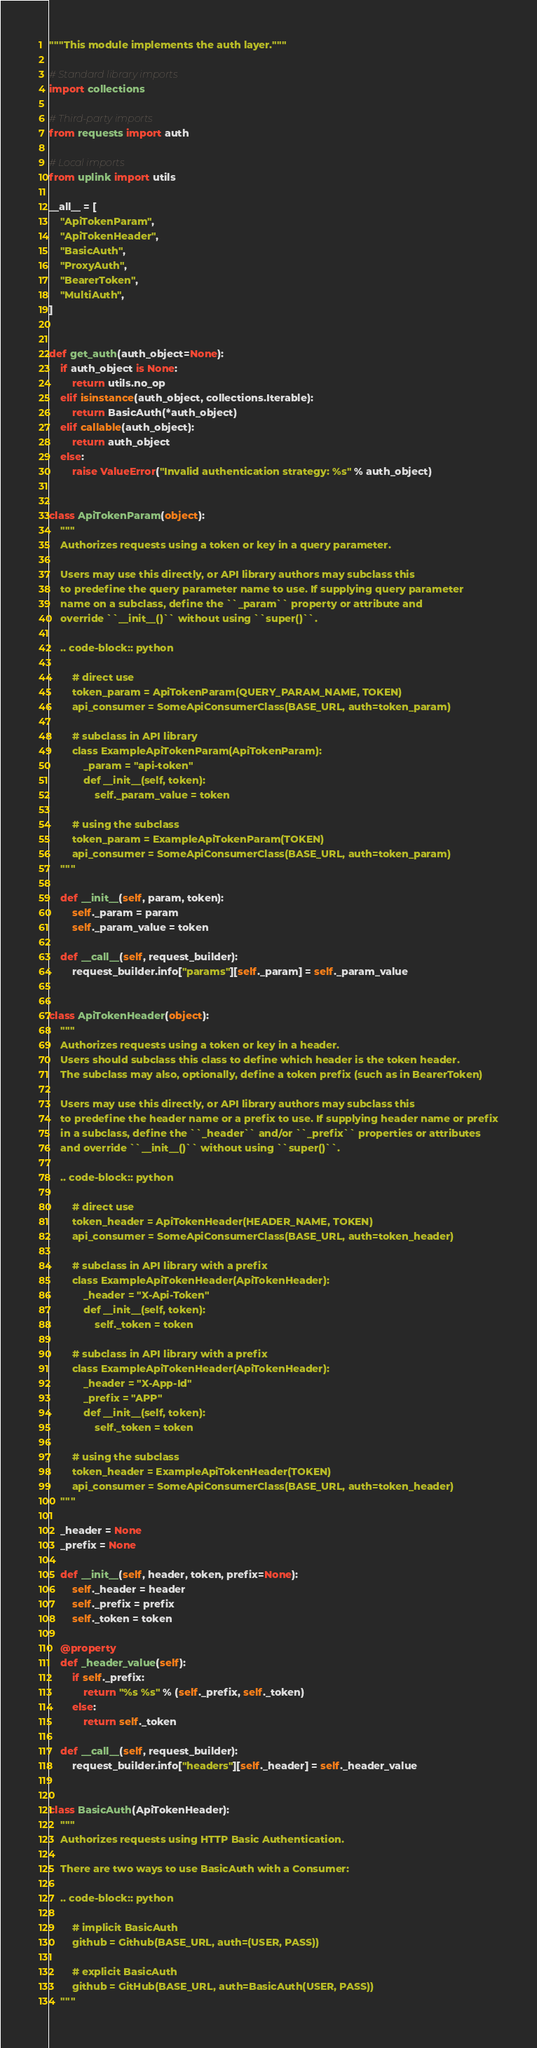<code> <loc_0><loc_0><loc_500><loc_500><_Python_>"""This module implements the auth layer."""

# Standard library imports
import collections

# Third-party imports
from requests import auth

# Local imports
from uplink import utils

__all__ = [
    "ApiTokenParam",
    "ApiTokenHeader",
    "BasicAuth",
    "ProxyAuth",
    "BearerToken",
    "MultiAuth",
]


def get_auth(auth_object=None):
    if auth_object is None:
        return utils.no_op
    elif isinstance(auth_object, collections.Iterable):
        return BasicAuth(*auth_object)
    elif callable(auth_object):
        return auth_object
    else:
        raise ValueError("Invalid authentication strategy: %s" % auth_object)


class ApiTokenParam(object):
    """
    Authorizes requests using a token or key in a query parameter.

    Users may use this directly, or API library authors may subclass this
    to predefine the query parameter name to use. If supplying query parameter
    name on a subclass, define the ``_param`` property or attribute and
    override ``__init__()`` without using ``super()``.

    .. code-block:: python

        # direct use
        token_param = ApiTokenParam(QUERY_PARAM_NAME, TOKEN)
        api_consumer = SomeApiConsumerClass(BASE_URL, auth=token_param)

        # subclass in API library
        class ExampleApiTokenParam(ApiTokenParam):
            _param = "api-token"
            def __init__(self, token):
                self._param_value = token

        # using the subclass
        token_param = ExampleApiTokenParam(TOKEN)
        api_consumer = SomeApiConsumerClass(BASE_URL, auth=token_param)
    """

    def __init__(self, param, token):
        self._param = param
        self._param_value = token

    def __call__(self, request_builder):
        request_builder.info["params"][self._param] = self._param_value


class ApiTokenHeader(object):
    """
    Authorizes requests using a token or key in a header.
    Users should subclass this class to define which header is the token header.
    The subclass may also, optionally, define a token prefix (such as in BearerToken)

    Users may use this directly, or API library authors may subclass this
    to predefine the header name or a prefix to use. If supplying header name or prefix
    in a subclass, define the ``_header`` and/or ``_prefix`` properties or attributes
    and override ``__init__()`` without using ``super()``.

    .. code-block:: python

        # direct use
        token_header = ApiTokenHeader(HEADER_NAME, TOKEN)
        api_consumer = SomeApiConsumerClass(BASE_URL, auth=token_header)

        # subclass in API library with a prefix
        class ExampleApiTokenHeader(ApiTokenHeader):
            _header = "X-Api-Token"
            def __init__(self, token):
                self._token = token

        # subclass in API library with a prefix
        class ExampleApiTokenHeader(ApiTokenHeader):
            _header = "X-App-Id"
            _prefix = "APP"
            def __init__(self, token):
                self._token = token

        # using the subclass
        token_header = ExampleApiTokenHeader(TOKEN)
        api_consumer = SomeApiConsumerClass(BASE_URL, auth=token_header)
    """

    _header = None
    _prefix = None

    def __init__(self, header, token, prefix=None):
        self._header = header
        self._prefix = prefix
        self._token = token

    @property
    def _header_value(self):
        if self._prefix:
            return "%s %s" % (self._prefix, self._token)
        else:
            return self._token

    def __call__(self, request_builder):
        request_builder.info["headers"][self._header] = self._header_value


class BasicAuth(ApiTokenHeader):
    """
    Authorizes requests using HTTP Basic Authentication.

    There are two ways to use BasicAuth with a Consumer:

    .. code-block:: python

        # implicit BasicAuth
        github = Github(BASE_URL, auth=(USER, PASS))

        # explicit BasicAuth
        github = GitHub(BASE_URL, auth=BasicAuth(USER, PASS))
    """
</code> 